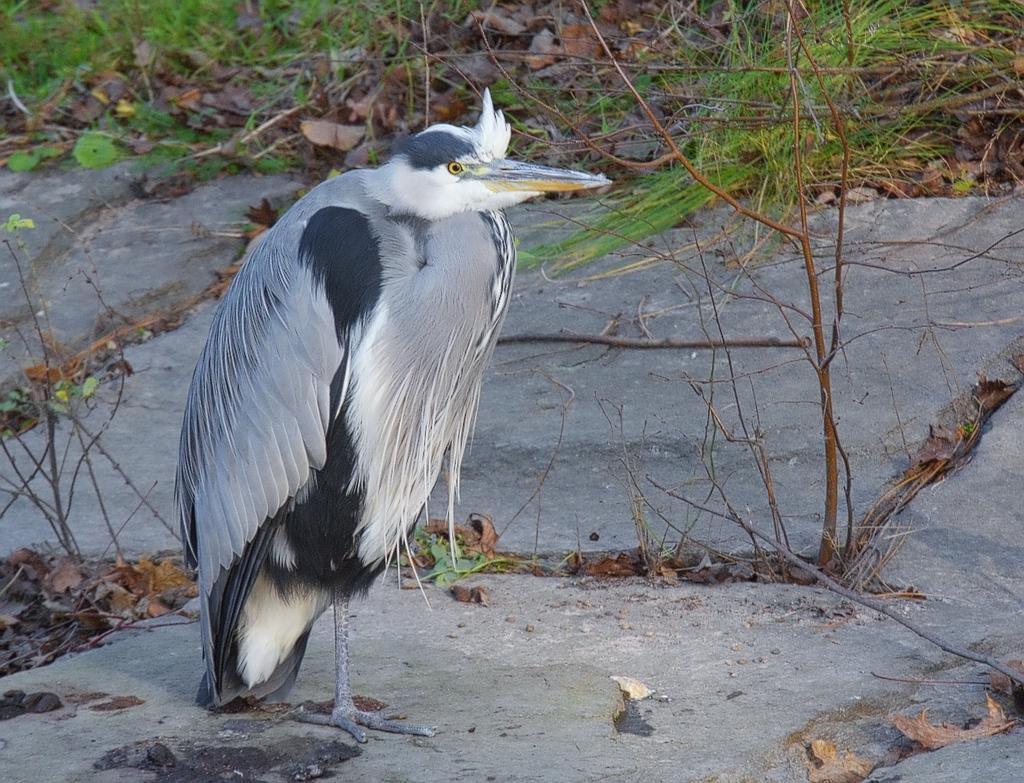Describe this image in one or two sentences. In this image there is a Black-crowned night heron bird standing on the rock, around the bird there are dry leaves, dry sticks and grass. 